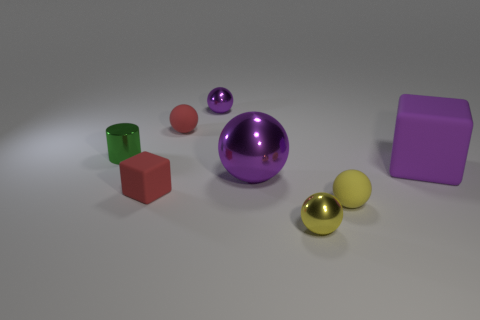Can you guess the texture of the objects just by looking at them? Based on their appearance, the spheres and the large cube have a reflective, smooth surface suggesting a metallic or polished texture, while the smaller cubes look matte, indicating a possibly softer or less reflective texture. 